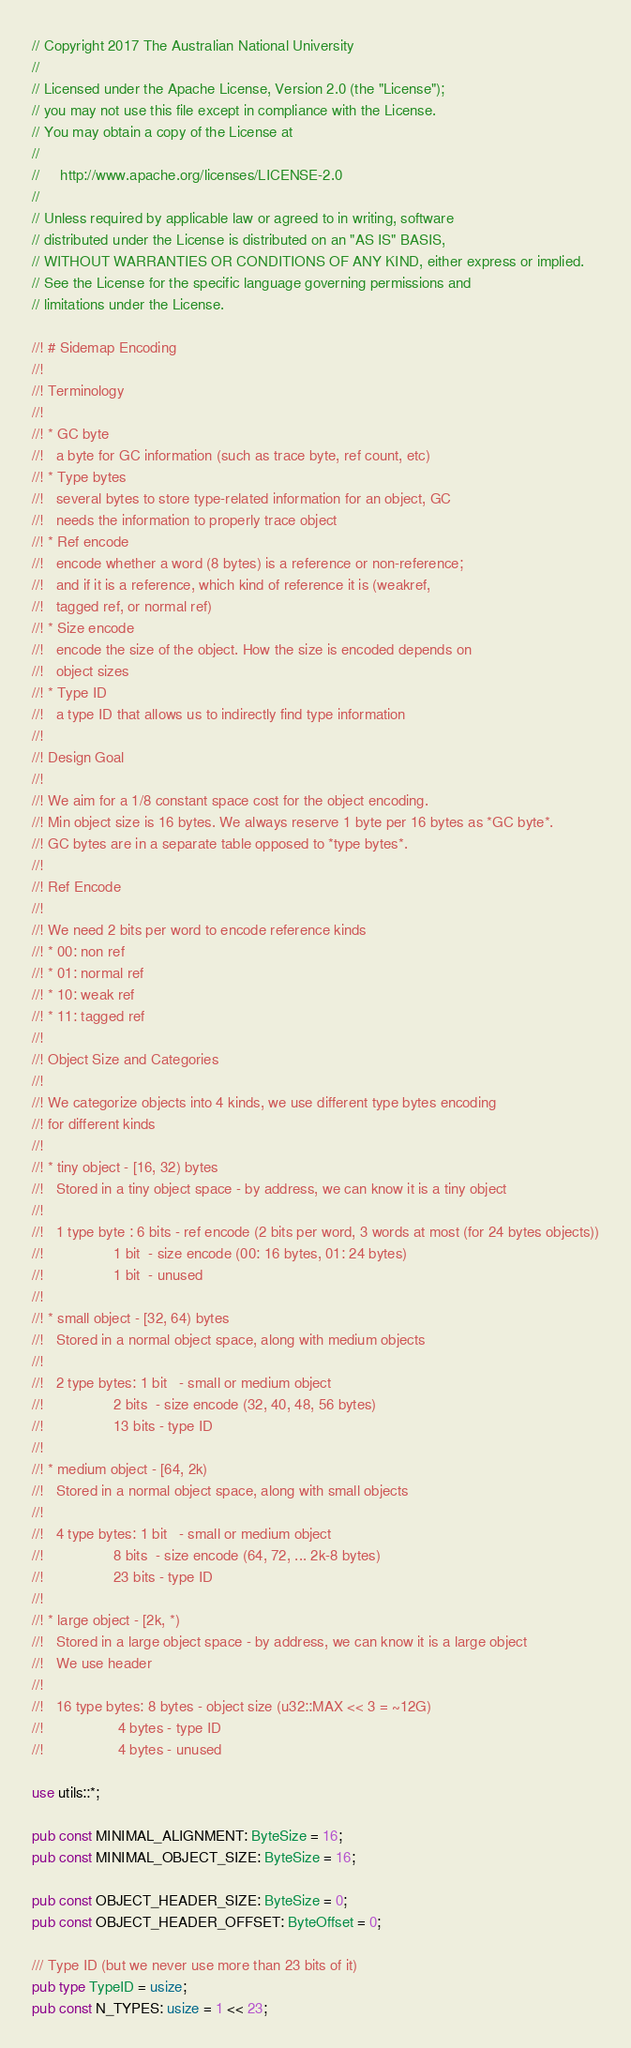<code> <loc_0><loc_0><loc_500><loc_500><_Rust_>// Copyright 2017 The Australian National University
//
// Licensed under the Apache License, Version 2.0 (the "License");
// you may not use this file except in compliance with the License.
// You may obtain a copy of the License at
//
//     http://www.apache.org/licenses/LICENSE-2.0
//
// Unless required by applicable law or agreed to in writing, software
// distributed under the License is distributed on an "AS IS" BASIS,
// WITHOUT WARRANTIES OR CONDITIONS OF ANY KIND, either express or implied.
// See the License for the specific language governing permissions and
// limitations under the License.

//! # Sidemap Encoding
//!
//! Terminology
//!
//! * GC byte
//!   a byte for GC information (such as trace byte, ref count, etc)
//! * Type bytes
//!   several bytes to store type-related information for an object, GC
//!   needs the information to properly trace object
//! * Ref encode
//!   encode whether a word (8 bytes) is a reference or non-reference;
//!   and if it is a reference, which kind of reference it is (weakref,
//!   tagged ref, or normal ref)
//! * Size encode
//!   encode the size of the object. How the size is encoded depends on
//!   object sizes
//! * Type ID
//!   a type ID that allows us to indirectly find type information
//!
//! Design Goal
//!
//! We aim for a 1/8 constant space cost for the object encoding.
//! Min object size is 16 bytes. We always reserve 1 byte per 16 bytes as *GC byte*.
//! GC bytes are in a separate table opposed to *type bytes*.
//!
//! Ref Encode
//!
//! We need 2 bits per word to encode reference kinds
//! * 00: non ref
//! * 01: normal ref
//! * 10: weak ref
//! * 11: tagged ref
//!
//! Object Size and Categories
//!
//! We categorize objects into 4 kinds, we use different type bytes encoding
//! for different kinds
//!
//! * tiny object - [16, 32) bytes
//!   Stored in a tiny object space - by address, we can know it is a tiny object
//!
//!   1 type byte : 6 bits - ref encode (2 bits per word, 3 words at most (for 24 bytes objects))
//!                 1 bit  - size encode (00: 16 bytes, 01: 24 bytes)
//!                 1 bit  - unused
//!
//! * small object - [32, 64) bytes
//!   Stored in a normal object space, along with medium objects
//!
//!   2 type bytes: 1 bit   - small or medium object
//!                 2 bits  - size encode (32, 40, 48, 56 bytes)
//!                 13 bits - type ID
//!
//! * medium object - [64, 2k)
//!   Stored in a normal object space, along with small objects
//!
//!   4 type bytes: 1 bit   - small or medium object
//!                 8 bits  - size encode (64, 72, ... 2k-8 bytes)
//!                 23 bits - type ID
//!
//! * large object - [2k, *)
//!   Stored in a large object space - by address, we can know it is a large object
//!   We use header
//!
//!   16 type bytes: 8 bytes - object size (u32::MAX << 3 = ~12G)
//!                  4 bytes - type ID
//!                  4 bytes - unused

use utils::*;

pub const MINIMAL_ALIGNMENT: ByteSize = 16;
pub const MINIMAL_OBJECT_SIZE: ByteSize = 16;

pub const OBJECT_HEADER_SIZE: ByteSize = 0;
pub const OBJECT_HEADER_OFFSET: ByteOffset = 0;

/// Type ID (but we never use more than 23 bits of it)
pub type TypeID = usize;
pub const N_TYPES: usize = 1 << 23;
</code> 